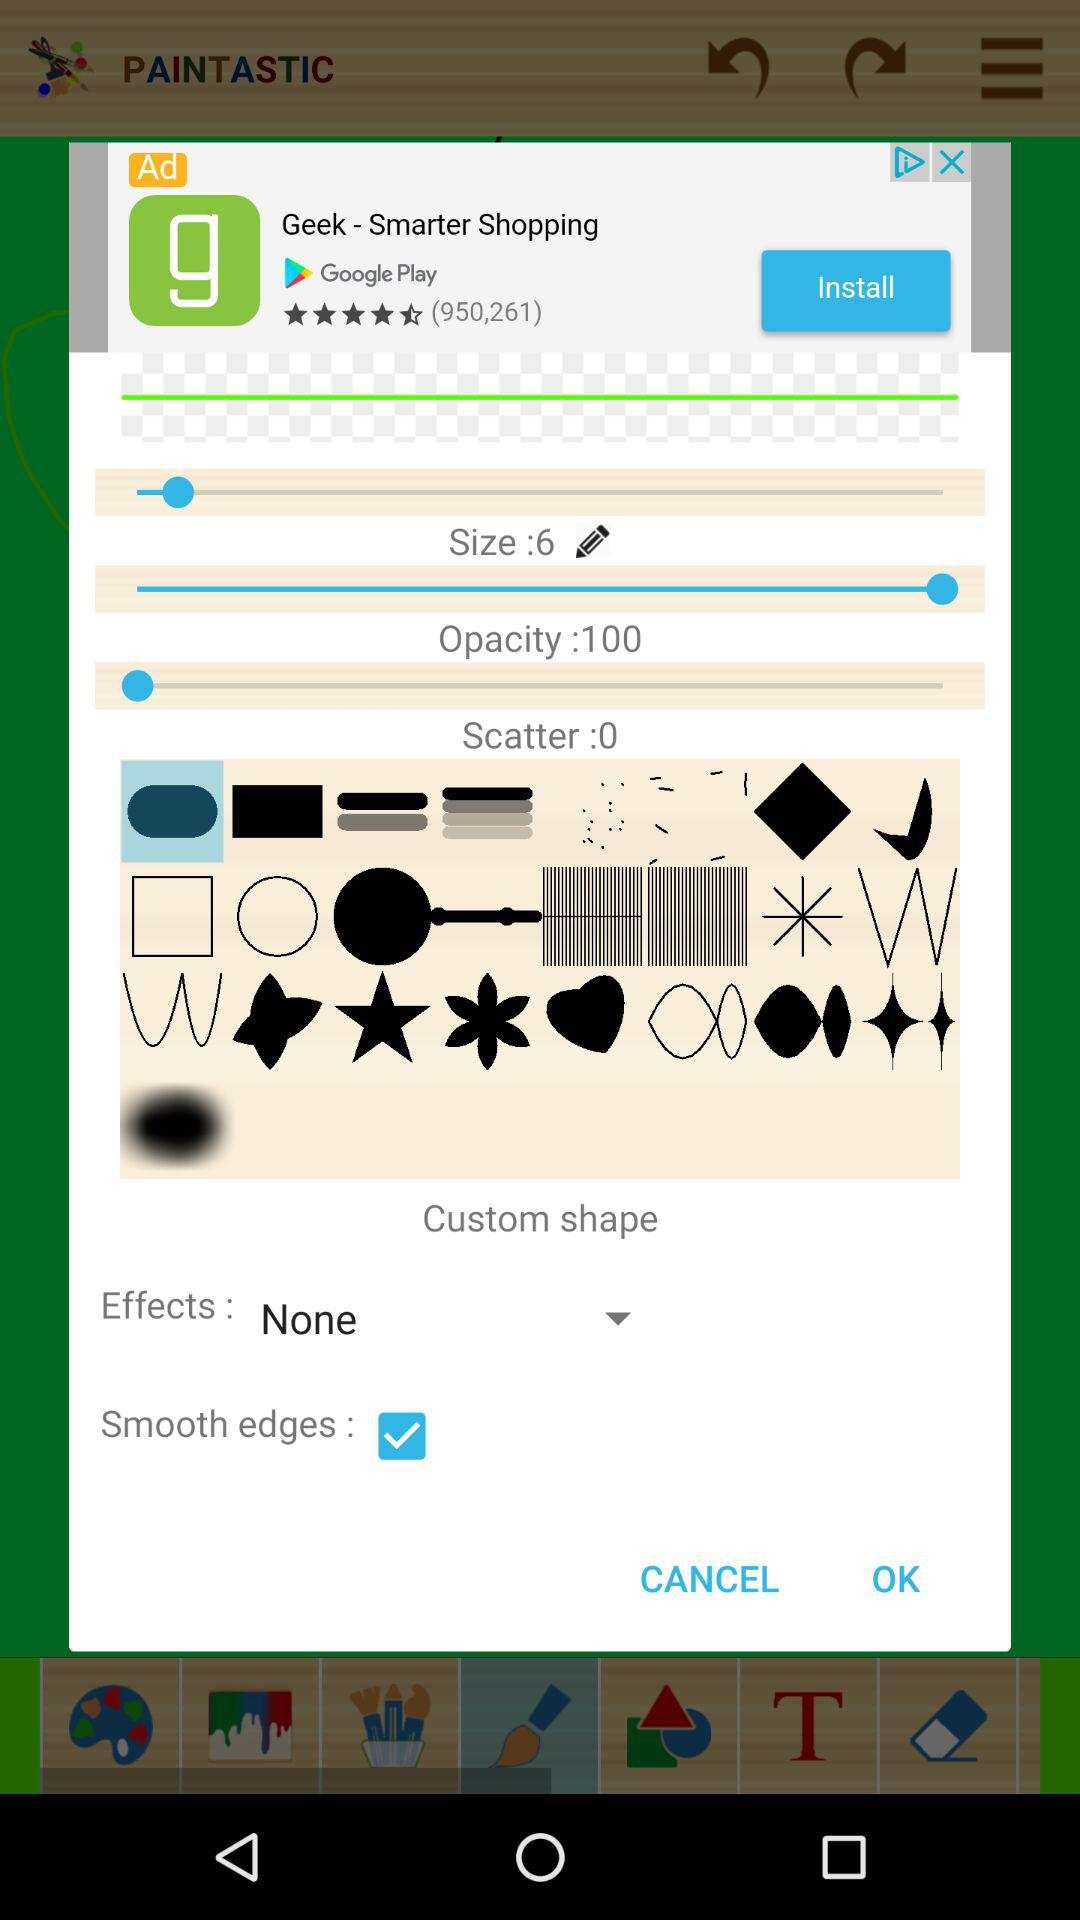What is the size? The size is 6. 